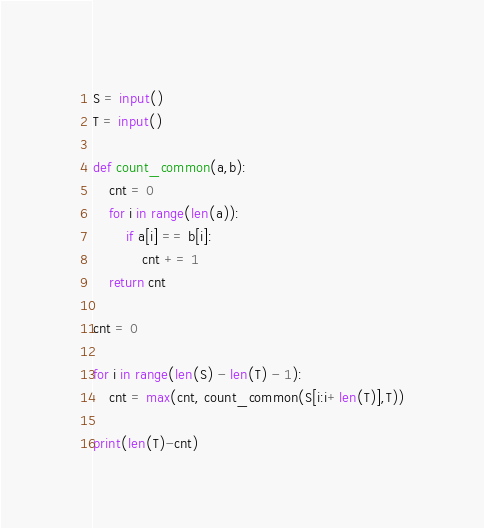Convert code to text. <code><loc_0><loc_0><loc_500><loc_500><_Python_>S = input()
T = input()

def count_common(a,b):
    cnt = 0
    for i in range(len(a)):
        if a[i] == b[i]:
            cnt += 1
    return cnt

cnt = 0

for i in range(len(S) - len(T) - 1):
    cnt = max(cnt, count_common(S[i:i+len(T)],T))

print(len(T)-cnt)</code> 